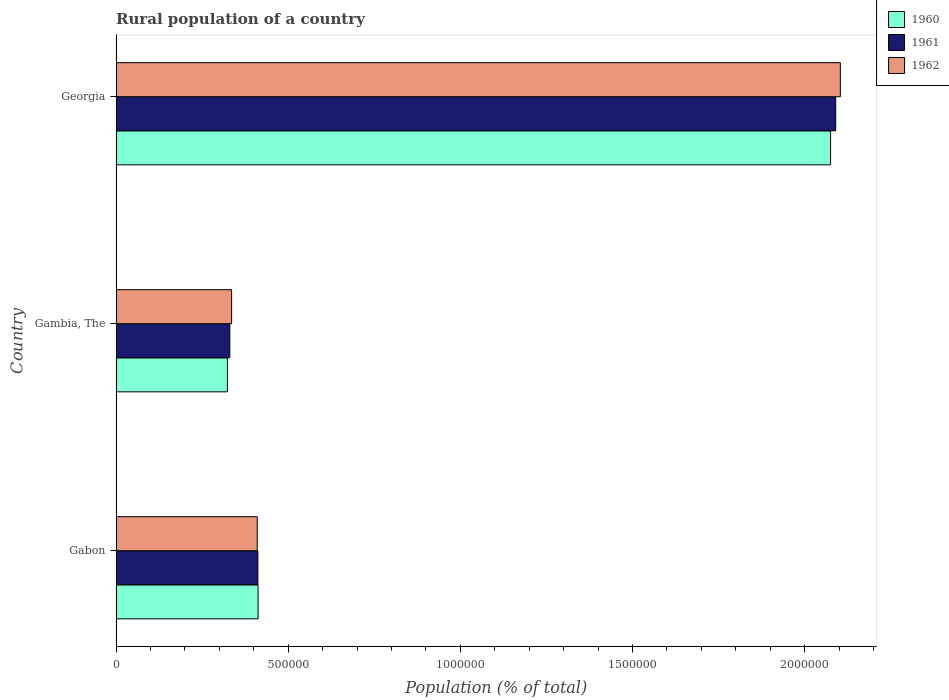How many different coloured bars are there?
Ensure brevity in your answer.  3. Are the number of bars on each tick of the Y-axis equal?
Provide a short and direct response. Yes. How many bars are there on the 1st tick from the top?
Provide a short and direct response. 3. How many bars are there on the 2nd tick from the bottom?
Ensure brevity in your answer.  3. What is the label of the 2nd group of bars from the top?
Your response must be concise. Gambia, The. In how many cases, is the number of bars for a given country not equal to the number of legend labels?
Your answer should be very brief. 0. What is the rural population in 1962 in Gambia, The?
Give a very brief answer. 3.35e+05. Across all countries, what is the maximum rural population in 1960?
Your response must be concise. 2.08e+06. Across all countries, what is the minimum rural population in 1962?
Keep it short and to the point. 3.35e+05. In which country was the rural population in 1962 maximum?
Offer a very short reply. Georgia. In which country was the rural population in 1960 minimum?
Offer a very short reply. Gambia, The. What is the total rural population in 1961 in the graph?
Your answer should be compact. 2.83e+06. What is the difference between the rural population in 1960 in Gabon and that in Georgia?
Offer a very short reply. -1.66e+06. What is the difference between the rural population in 1961 in Gabon and the rural population in 1960 in Georgia?
Your answer should be very brief. -1.66e+06. What is the average rural population in 1960 per country?
Provide a short and direct response. 9.37e+05. What is the difference between the rural population in 1960 and rural population in 1961 in Gambia, The?
Your response must be concise. -6978. What is the ratio of the rural population in 1961 in Gabon to that in Gambia, The?
Offer a very short reply. 1.25. Is the difference between the rural population in 1960 in Gabon and Georgia greater than the difference between the rural population in 1961 in Gabon and Georgia?
Your response must be concise. Yes. What is the difference between the highest and the second highest rural population in 1961?
Your answer should be very brief. 1.68e+06. What is the difference between the highest and the lowest rural population in 1960?
Ensure brevity in your answer.  1.75e+06. In how many countries, is the rural population in 1960 greater than the average rural population in 1960 taken over all countries?
Provide a short and direct response. 1. What does the 3rd bar from the top in Georgia represents?
Provide a short and direct response. 1960. What does the 2nd bar from the bottom in Georgia represents?
Offer a very short reply. 1961. Is it the case that in every country, the sum of the rural population in 1960 and rural population in 1961 is greater than the rural population in 1962?
Your response must be concise. Yes. Are all the bars in the graph horizontal?
Make the answer very short. Yes. How many countries are there in the graph?
Provide a succinct answer. 3. What is the difference between two consecutive major ticks on the X-axis?
Your response must be concise. 5.00e+05. Are the values on the major ticks of X-axis written in scientific E-notation?
Keep it short and to the point. No. Where does the legend appear in the graph?
Keep it short and to the point. Top right. What is the title of the graph?
Give a very brief answer. Rural population of a country. What is the label or title of the X-axis?
Provide a succinct answer. Population (% of total). What is the label or title of the Y-axis?
Offer a terse response. Country. What is the Population (% of total) in 1960 in Gabon?
Your answer should be compact. 4.12e+05. What is the Population (% of total) of 1961 in Gabon?
Provide a short and direct response. 4.12e+05. What is the Population (% of total) of 1962 in Gabon?
Keep it short and to the point. 4.10e+05. What is the Population (% of total) in 1960 in Gambia, The?
Ensure brevity in your answer.  3.23e+05. What is the Population (% of total) of 1961 in Gambia, The?
Make the answer very short. 3.30e+05. What is the Population (% of total) of 1962 in Gambia, The?
Provide a succinct answer. 3.35e+05. What is the Population (% of total) in 1960 in Georgia?
Provide a succinct answer. 2.08e+06. What is the Population (% of total) in 1961 in Georgia?
Provide a succinct answer. 2.09e+06. What is the Population (% of total) of 1962 in Georgia?
Offer a terse response. 2.10e+06. Across all countries, what is the maximum Population (% of total) in 1960?
Keep it short and to the point. 2.08e+06. Across all countries, what is the maximum Population (% of total) of 1961?
Your answer should be compact. 2.09e+06. Across all countries, what is the maximum Population (% of total) in 1962?
Keep it short and to the point. 2.10e+06. Across all countries, what is the minimum Population (% of total) of 1960?
Your response must be concise. 3.23e+05. Across all countries, what is the minimum Population (% of total) in 1961?
Your response must be concise. 3.30e+05. Across all countries, what is the minimum Population (% of total) in 1962?
Your response must be concise. 3.35e+05. What is the total Population (% of total) of 1960 in the graph?
Your answer should be compact. 2.81e+06. What is the total Population (% of total) of 1961 in the graph?
Offer a very short reply. 2.83e+06. What is the total Population (% of total) in 1962 in the graph?
Provide a succinct answer. 2.85e+06. What is the difference between the Population (% of total) in 1960 in Gabon and that in Gambia, The?
Make the answer very short. 8.90e+04. What is the difference between the Population (% of total) in 1961 in Gabon and that in Gambia, The?
Offer a very short reply. 8.15e+04. What is the difference between the Population (% of total) of 1962 in Gabon and that in Gambia, The?
Your answer should be very brief. 7.45e+04. What is the difference between the Population (% of total) in 1960 in Gabon and that in Georgia?
Make the answer very short. -1.66e+06. What is the difference between the Population (% of total) in 1961 in Gabon and that in Georgia?
Keep it short and to the point. -1.68e+06. What is the difference between the Population (% of total) in 1962 in Gabon and that in Georgia?
Your answer should be very brief. -1.69e+06. What is the difference between the Population (% of total) in 1960 in Gambia, The and that in Georgia?
Provide a succinct answer. -1.75e+06. What is the difference between the Population (% of total) in 1961 in Gambia, The and that in Georgia?
Offer a very short reply. -1.76e+06. What is the difference between the Population (% of total) in 1962 in Gambia, The and that in Georgia?
Provide a short and direct response. -1.77e+06. What is the difference between the Population (% of total) in 1960 in Gabon and the Population (% of total) in 1961 in Gambia, The?
Ensure brevity in your answer.  8.21e+04. What is the difference between the Population (% of total) of 1960 in Gabon and the Population (% of total) of 1962 in Gambia, The?
Ensure brevity in your answer.  7.69e+04. What is the difference between the Population (% of total) of 1961 in Gabon and the Population (% of total) of 1962 in Gambia, The?
Your response must be concise. 7.63e+04. What is the difference between the Population (% of total) in 1960 in Gabon and the Population (% of total) in 1961 in Georgia?
Your answer should be very brief. -1.68e+06. What is the difference between the Population (% of total) of 1960 in Gabon and the Population (% of total) of 1962 in Georgia?
Your answer should be compact. -1.69e+06. What is the difference between the Population (% of total) in 1961 in Gabon and the Population (% of total) in 1962 in Georgia?
Offer a terse response. -1.69e+06. What is the difference between the Population (% of total) of 1960 in Gambia, The and the Population (% of total) of 1961 in Georgia?
Keep it short and to the point. -1.77e+06. What is the difference between the Population (% of total) in 1960 in Gambia, The and the Population (% of total) in 1962 in Georgia?
Your answer should be very brief. -1.78e+06. What is the difference between the Population (% of total) of 1961 in Gambia, The and the Population (% of total) of 1962 in Georgia?
Offer a very short reply. -1.77e+06. What is the average Population (% of total) in 1960 per country?
Your response must be concise. 9.37e+05. What is the average Population (% of total) in 1961 per country?
Your response must be concise. 9.44e+05. What is the average Population (% of total) of 1962 per country?
Provide a succinct answer. 9.50e+05. What is the difference between the Population (% of total) in 1960 and Population (% of total) in 1961 in Gabon?
Provide a short and direct response. 581. What is the difference between the Population (% of total) of 1960 and Population (% of total) of 1962 in Gabon?
Offer a very short reply. 2425. What is the difference between the Population (% of total) of 1961 and Population (% of total) of 1962 in Gabon?
Provide a short and direct response. 1844. What is the difference between the Population (% of total) of 1960 and Population (% of total) of 1961 in Gambia, The?
Keep it short and to the point. -6978. What is the difference between the Population (% of total) in 1960 and Population (% of total) in 1962 in Gambia, The?
Offer a very short reply. -1.21e+04. What is the difference between the Population (% of total) of 1961 and Population (% of total) of 1962 in Gambia, The?
Ensure brevity in your answer.  -5169. What is the difference between the Population (% of total) in 1960 and Population (% of total) in 1961 in Georgia?
Give a very brief answer. -1.49e+04. What is the difference between the Population (% of total) of 1960 and Population (% of total) of 1962 in Georgia?
Offer a terse response. -2.84e+04. What is the difference between the Population (% of total) of 1961 and Population (% of total) of 1962 in Georgia?
Provide a short and direct response. -1.35e+04. What is the ratio of the Population (% of total) of 1960 in Gabon to that in Gambia, The?
Provide a succinct answer. 1.28. What is the ratio of the Population (% of total) in 1961 in Gabon to that in Gambia, The?
Keep it short and to the point. 1.25. What is the ratio of the Population (% of total) of 1962 in Gabon to that in Gambia, The?
Give a very brief answer. 1.22. What is the ratio of the Population (% of total) of 1960 in Gabon to that in Georgia?
Keep it short and to the point. 0.2. What is the ratio of the Population (% of total) of 1961 in Gabon to that in Georgia?
Offer a terse response. 0.2. What is the ratio of the Population (% of total) in 1962 in Gabon to that in Georgia?
Keep it short and to the point. 0.19. What is the ratio of the Population (% of total) of 1960 in Gambia, The to that in Georgia?
Give a very brief answer. 0.16. What is the ratio of the Population (% of total) of 1961 in Gambia, The to that in Georgia?
Provide a succinct answer. 0.16. What is the ratio of the Population (% of total) in 1962 in Gambia, The to that in Georgia?
Your response must be concise. 0.16. What is the difference between the highest and the second highest Population (% of total) in 1960?
Your answer should be compact. 1.66e+06. What is the difference between the highest and the second highest Population (% of total) in 1961?
Ensure brevity in your answer.  1.68e+06. What is the difference between the highest and the second highest Population (% of total) of 1962?
Your response must be concise. 1.69e+06. What is the difference between the highest and the lowest Population (% of total) in 1960?
Give a very brief answer. 1.75e+06. What is the difference between the highest and the lowest Population (% of total) of 1961?
Offer a very short reply. 1.76e+06. What is the difference between the highest and the lowest Population (% of total) of 1962?
Your response must be concise. 1.77e+06. 